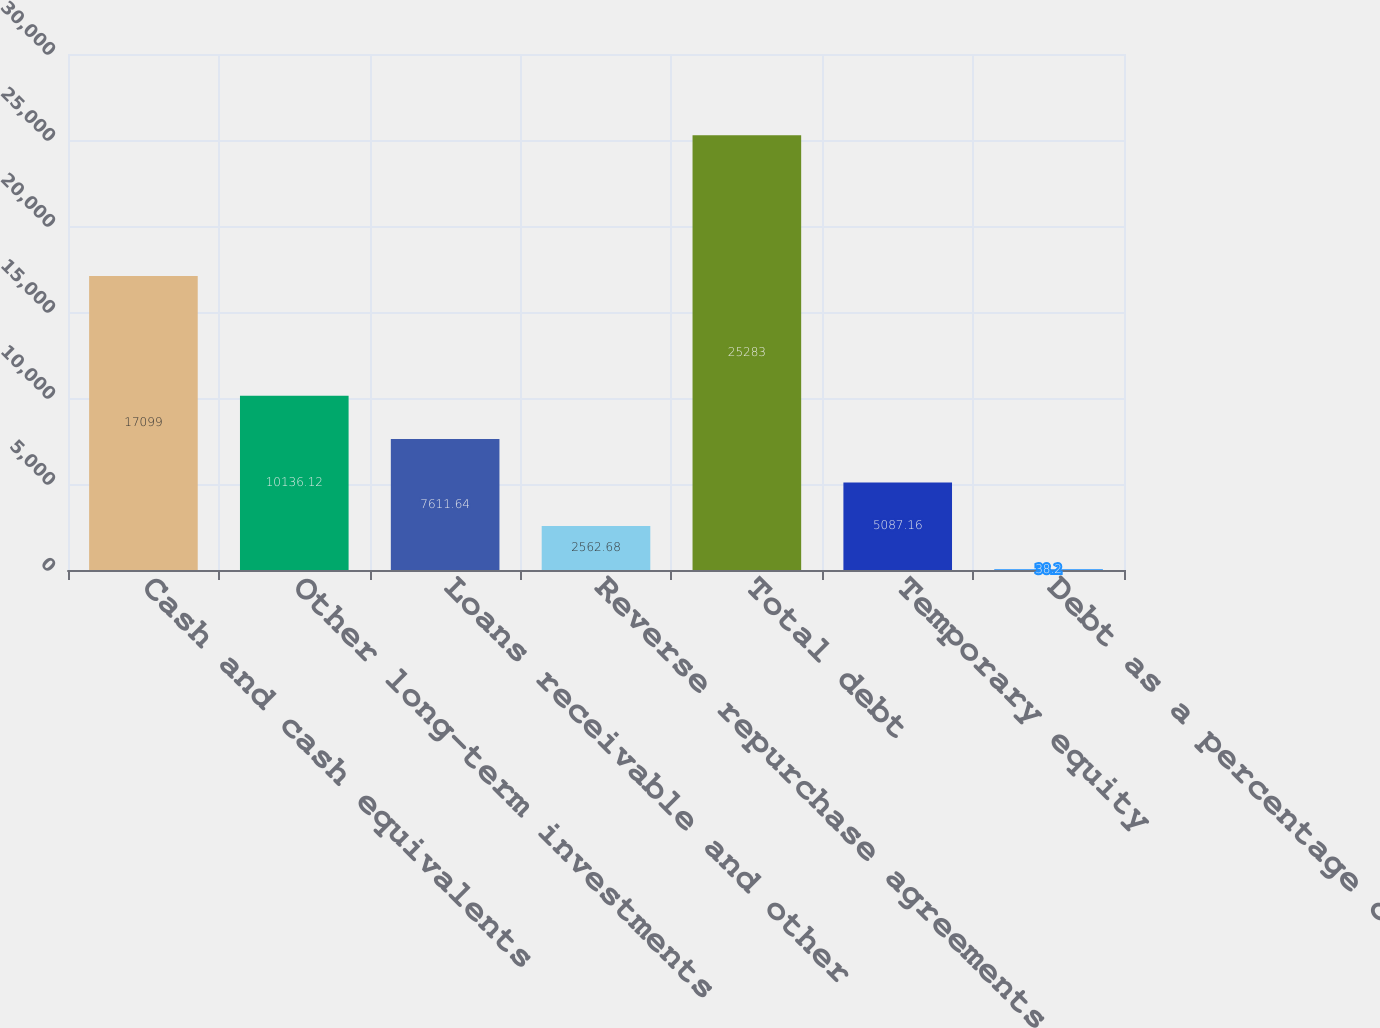Convert chart to OTSL. <chart><loc_0><loc_0><loc_500><loc_500><bar_chart><fcel>Cash and cash equivalents<fcel>Other long-term investments<fcel>Loans receivable and other<fcel>Reverse repurchase agreements<fcel>Total debt<fcel>Temporary equity<fcel>Debt as a percentage of<nl><fcel>17099<fcel>10136.1<fcel>7611.64<fcel>2562.68<fcel>25283<fcel>5087.16<fcel>38.2<nl></chart> 